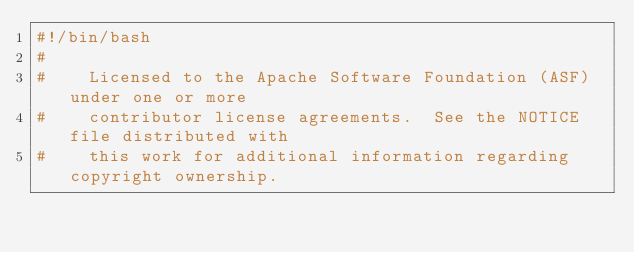<code> <loc_0><loc_0><loc_500><loc_500><_Bash_>#!/bin/bash
#
#    Licensed to the Apache Software Foundation (ASF) under one or more
#    contributor license agreements.  See the NOTICE file distributed with
#    this work for additional information regarding copyright ownership.</code> 